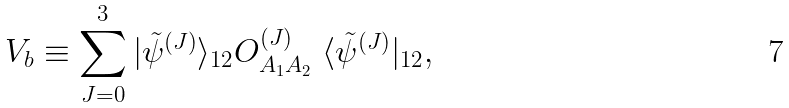Convert formula to latex. <formula><loc_0><loc_0><loc_500><loc_500>V _ { b } \equiv \sum _ { J = 0 } ^ { 3 } | \tilde { \psi } ^ { ( J ) } \rangle _ { 1 2 } O _ { A _ { 1 } A _ { 2 } } ^ { ( J ) } \ \langle \tilde { \psi } ^ { ( J ) } | _ { 1 2 } ,</formula> 